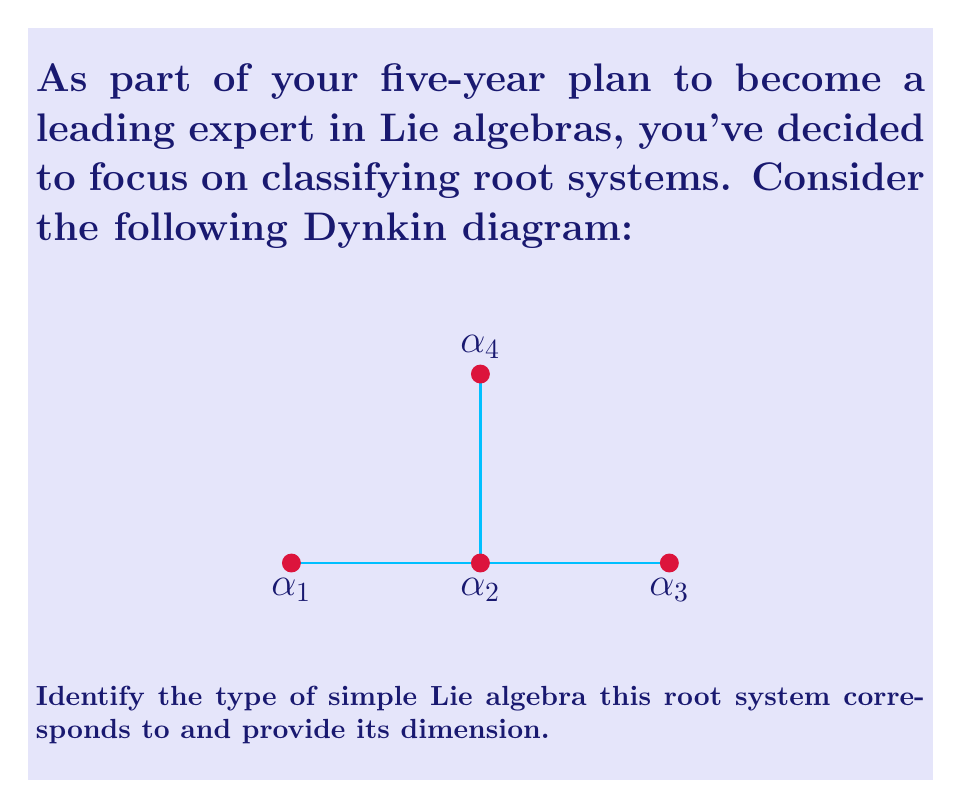Can you solve this math problem? To classify this root system and determine the corresponding simple Lie algebra, we'll follow these steps:

1) Analyze the Dynkin diagram:
   - It has 4 nodes, representing 4 simple roots: $\alpha_1$, $\alpha_2$, $\alpha_3$, and $\alpha_4$.
   - The diagram has a central node ($\alpha_2$) connected to three others.

2) Recognize the pattern:
   - This configuration matches the Dynkin diagram for the $D_4$ root system.

3) Identify the Lie algebra:
   - The $D_4$ root system corresponds to the simple Lie algebra $\mathfrak{so}(8)$, which is the special orthogonal Lie algebra in 8 dimensions.

4) Calculate the dimension:
   - For $D_n$ type Lie algebras, the dimension is given by $n(2n-1)$.
   - In this case, $n = 4$, so the dimension is:
     $$4(2(4)-1) = 4(8-1) = 4(7) = 28$$

Therefore, this root system corresponds to the simple Lie algebra $\mathfrak{so}(8)$ of dimension 28.
Answer: $D_4$, $\mathfrak{so}(8)$, dimension 28 